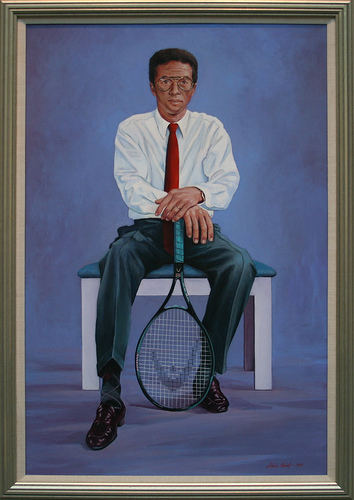Can you describe the setting or background in the image? The background of the image features a uniform blue color. It appears smooth and gradient, creating a calm and serene atmosphere for the subject. The man is seated on a simple, white bench that contrasts nicely with the blue background. 